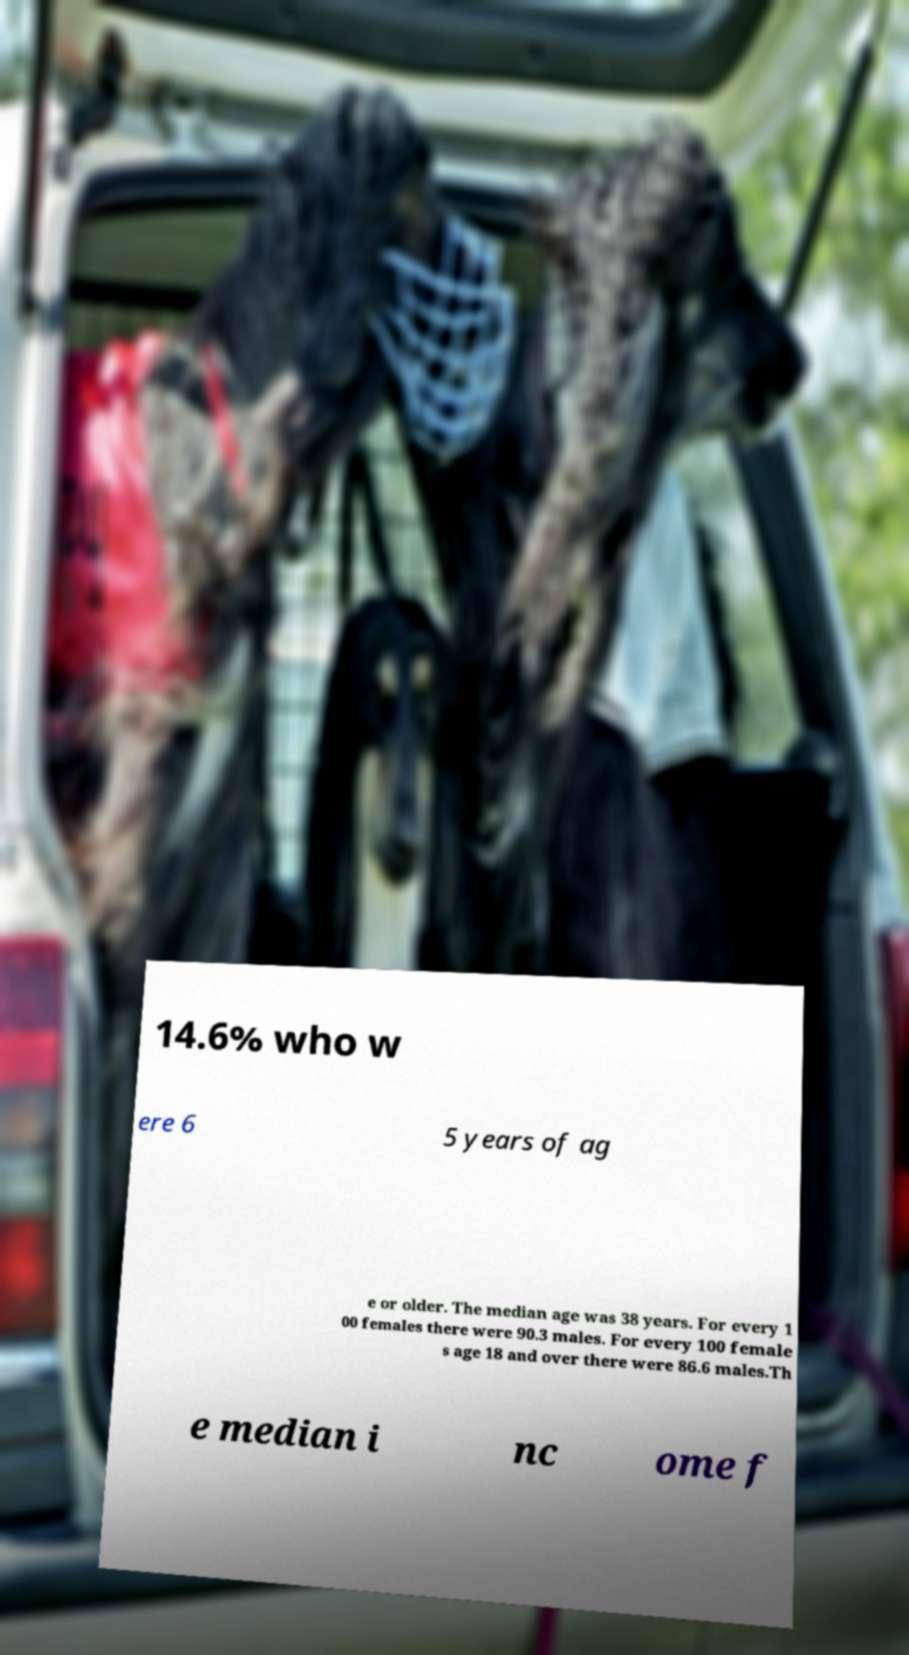I need the written content from this picture converted into text. Can you do that? 14.6% who w ere 6 5 years of ag e or older. The median age was 38 years. For every 1 00 females there were 90.3 males. For every 100 female s age 18 and over there were 86.6 males.Th e median i nc ome f 